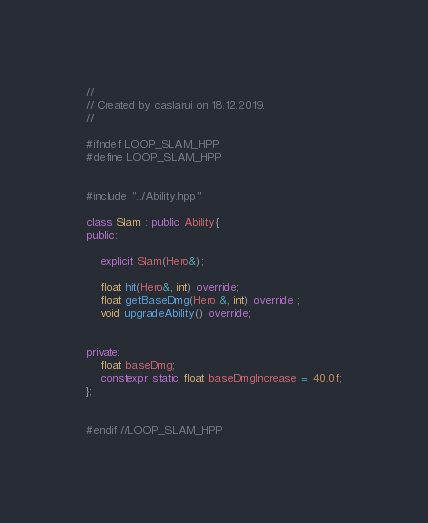Convert code to text. <code><loc_0><loc_0><loc_500><loc_500><_C++_>//
// Created by caslarui on 18.12.2019.
//

#ifndef LOOP_SLAM_HPP
#define LOOP_SLAM_HPP


#include "../Ability.hpp"

class Slam : public Ability{
public:

    explicit Slam(Hero&);

    float hit(Hero&, int) override;
    float getBaseDmg(Hero &, int) override ;
    void upgradeAbility() override;


private:
    float baseDmg;
    constexpr static float baseDmgIncrease = 40.0f;
};


#endif //LOOP_SLAM_HPP
</code> 